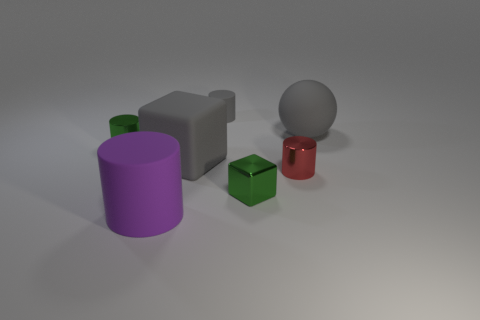Subtract all blue cylinders. Subtract all green balls. How many cylinders are left? 4 Add 1 purple metallic balls. How many objects exist? 8 Subtract all cylinders. How many objects are left? 3 Add 6 big objects. How many big objects are left? 9 Add 5 tiny blue matte cylinders. How many tiny blue matte cylinders exist? 5 Subtract 1 red cylinders. How many objects are left? 6 Subtract all metal objects. Subtract all cylinders. How many objects are left? 0 